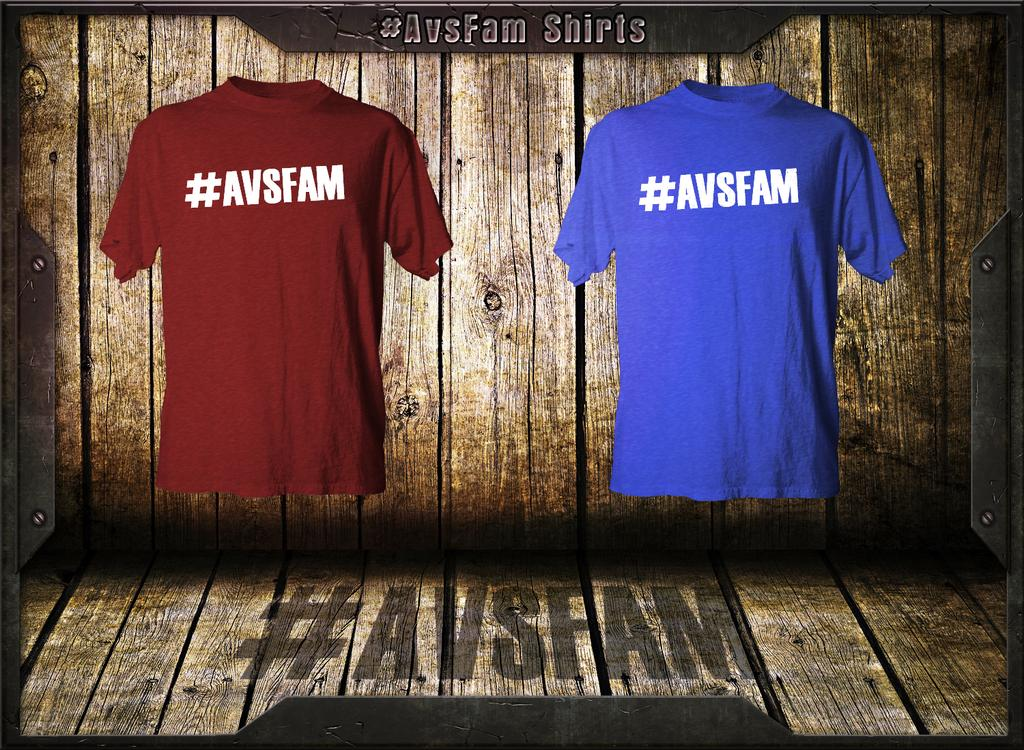<image>
Write a terse but informative summary of the picture. An ad for shirts that have #AVSFAM on them. 